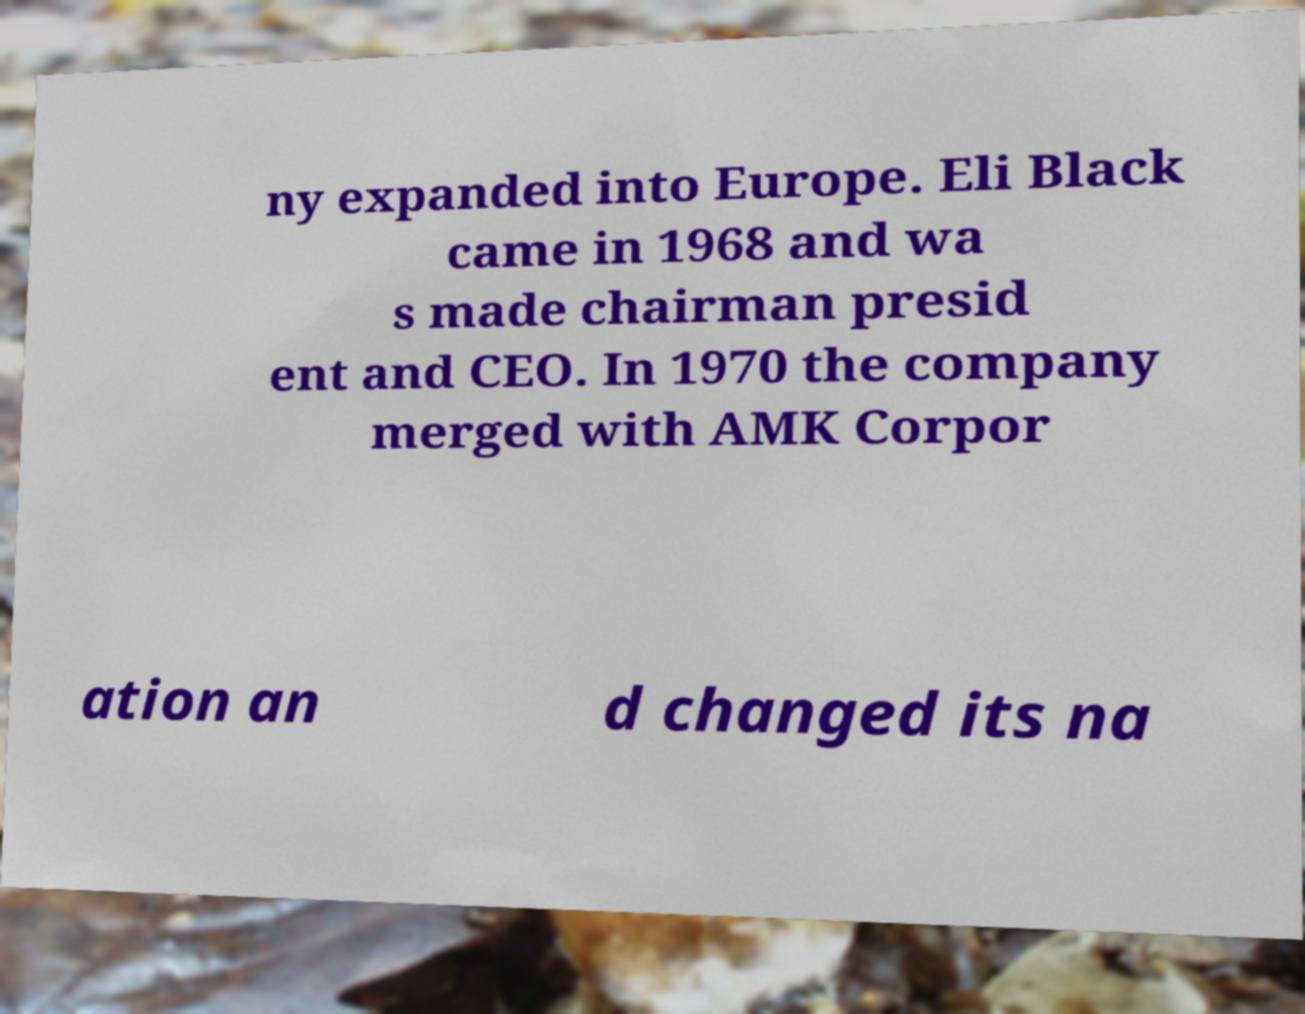Please read and relay the text visible in this image. What does it say? ny expanded into Europe. Eli Black came in 1968 and wa s made chairman presid ent and CEO. In 1970 the company merged with AMK Corpor ation an d changed its na 